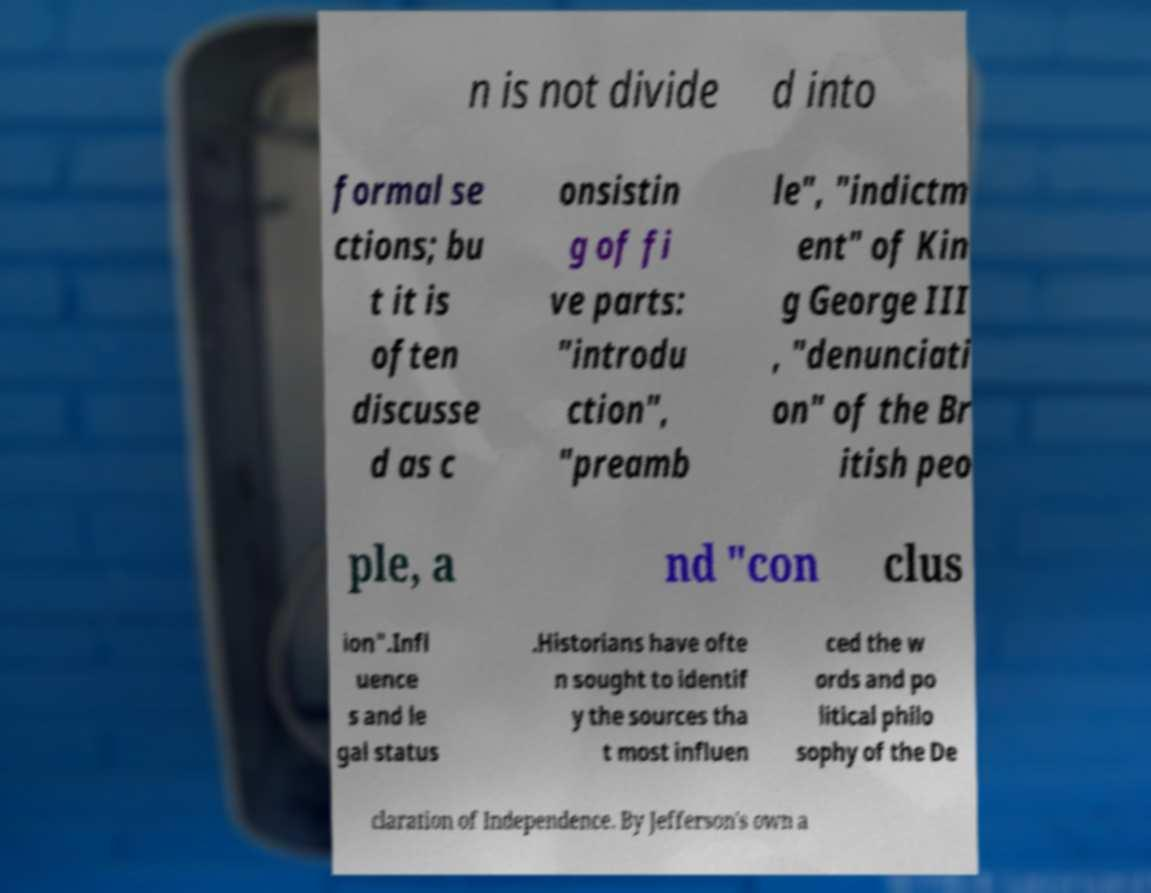Can you accurately transcribe the text from the provided image for me? n is not divide d into formal se ctions; bu t it is often discusse d as c onsistin g of fi ve parts: "introdu ction", "preamb le", "indictm ent" of Kin g George III , "denunciati on" of the Br itish peo ple, a nd "con clus ion".Infl uence s and le gal status .Historians have ofte n sought to identif y the sources tha t most influen ced the w ords and po litical philo sophy of the De claration of Independence. By Jefferson's own a 